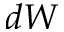<formula> <loc_0><loc_0><loc_500><loc_500>d W</formula> 